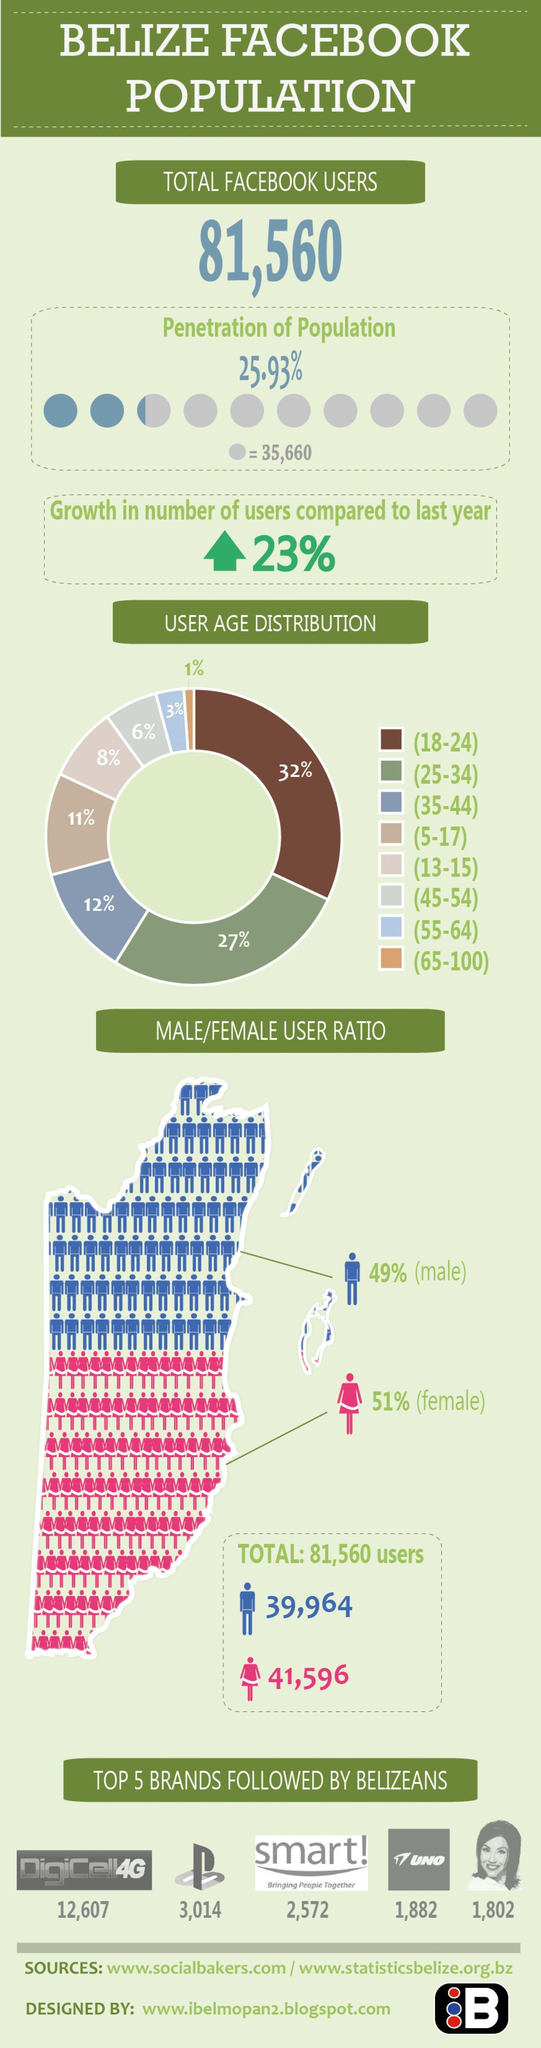What is the percentage of users in the age group 25-34 and 35-44, taken together?
Answer the question with a short phrase. 39% What is the percentage of users in the age group 5-17 and 45-54, taken together? 17% 